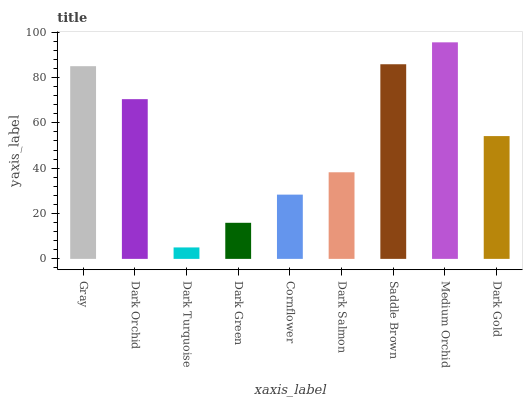Is Dark Turquoise the minimum?
Answer yes or no. Yes. Is Medium Orchid the maximum?
Answer yes or no. Yes. Is Dark Orchid the minimum?
Answer yes or no. No. Is Dark Orchid the maximum?
Answer yes or no. No. Is Gray greater than Dark Orchid?
Answer yes or no. Yes. Is Dark Orchid less than Gray?
Answer yes or no. Yes. Is Dark Orchid greater than Gray?
Answer yes or no. No. Is Gray less than Dark Orchid?
Answer yes or no. No. Is Dark Gold the high median?
Answer yes or no. Yes. Is Dark Gold the low median?
Answer yes or no. Yes. Is Dark Salmon the high median?
Answer yes or no. No. Is Gray the low median?
Answer yes or no. No. 